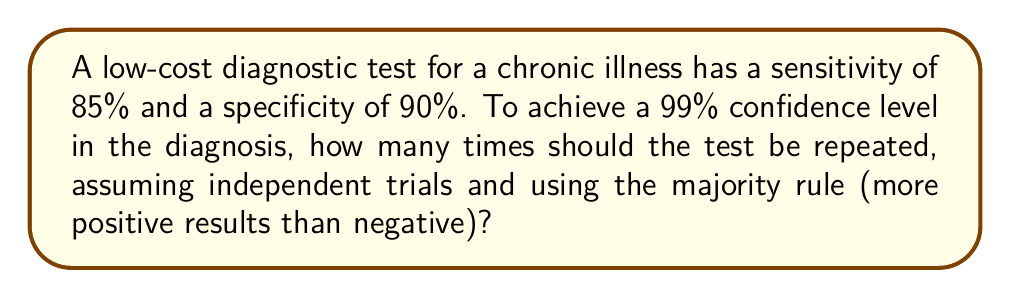Show me your answer to this math problem. Let's approach this step-by-step:

1) First, we need to understand what a 99% confidence level means. It means that the probability of getting the correct diagnosis should be at least 0.99.

2) Let $n$ be the number of tests performed. We need an odd number of tests to have a clear majority, so $n = 2k+1$ where $k$ is a non-negative integer.

3) The probability of a correct positive result (true positive) is 0.85, and the probability of a correct negative result (true negative) is 0.90.

4) We'll use the average of these probabilities, $p = \frac{0.85 + 0.90}{2} = 0.875$, as the probability of a correct result for any single test.

5) The probability of getting a correct majority out of $n$ tests is given by the cumulative binomial probability:

   $$P(\text{correct}) = \sum_{i=k+1}^n \binom{n}{i} p^i (1-p)^{n-i}$$

6) We need to find the smallest odd $n$ such that $P(\text{correct}) \geq 0.99$

7) Let's try some values:
   For $n = 3$ (k = 1): $P(\text{correct}) = 0.984375 < 0.99$
   For $n = 5$ (k = 2): $P(\text{correct}) = 0.998047 > 0.99$

8) Therefore, the minimum number of tests needed is 5.
Answer: 5 tests 